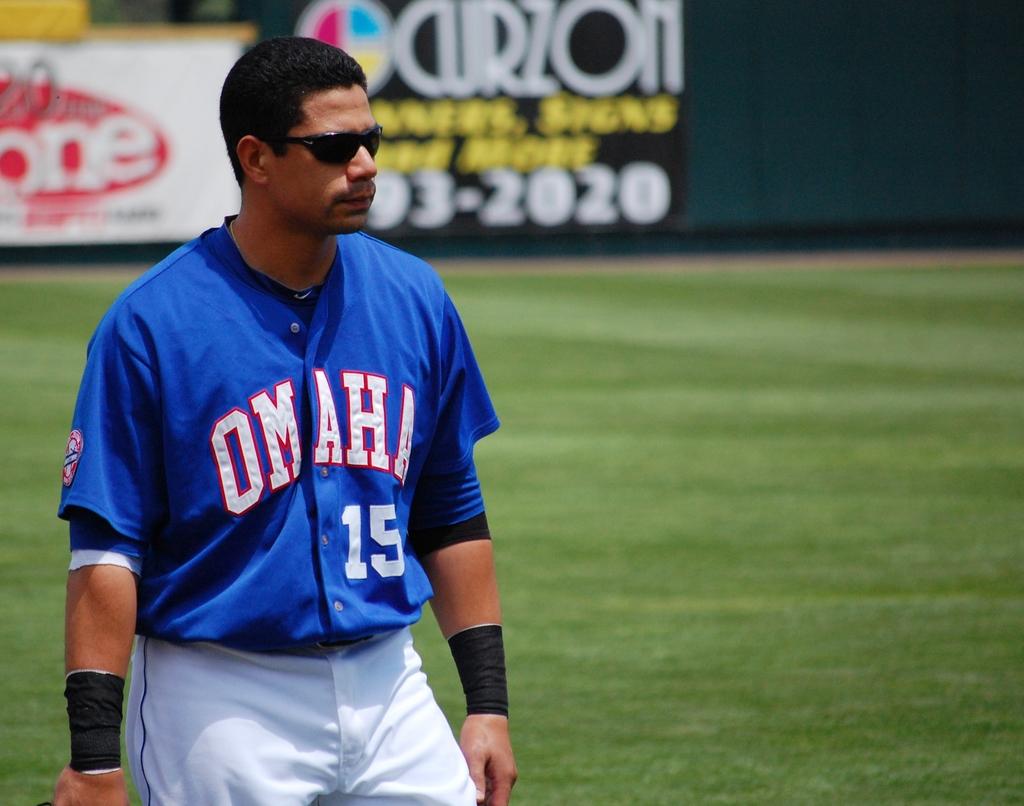What number is this player?
Offer a very short reply. 15. What team is on the jersey?
Keep it short and to the point. Omaha. 